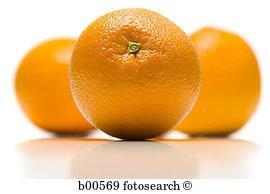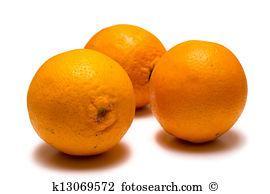The first image is the image on the left, the second image is the image on the right. Considering the images on both sides, is "The right image includes green leaves with three whole oranges, and one image includes two cut orange parts." valid? Answer yes or no. No. The first image is the image on the left, the second image is the image on the right. Evaluate the accuracy of this statement regarding the images: "One photo has greenery and one photo has an orange that is cut, and all photos have at least three oranges.". Is it true? Answer yes or no. No. 